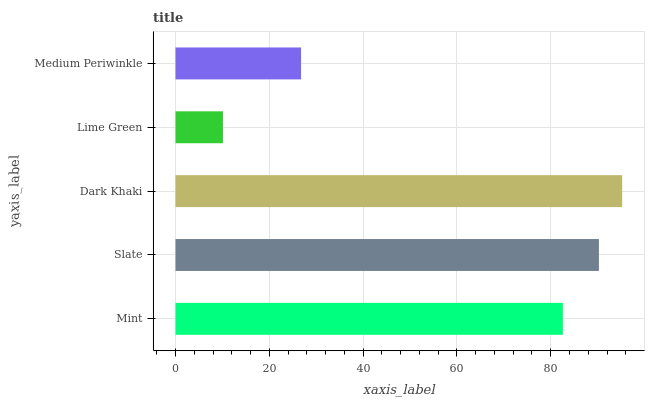Is Lime Green the minimum?
Answer yes or no. Yes. Is Dark Khaki the maximum?
Answer yes or no. Yes. Is Slate the minimum?
Answer yes or no. No. Is Slate the maximum?
Answer yes or no. No. Is Slate greater than Mint?
Answer yes or no. Yes. Is Mint less than Slate?
Answer yes or no. Yes. Is Mint greater than Slate?
Answer yes or no. No. Is Slate less than Mint?
Answer yes or no. No. Is Mint the high median?
Answer yes or no. Yes. Is Mint the low median?
Answer yes or no. Yes. Is Dark Khaki the high median?
Answer yes or no. No. Is Medium Periwinkle the low median?
Answer yes or no. No. 